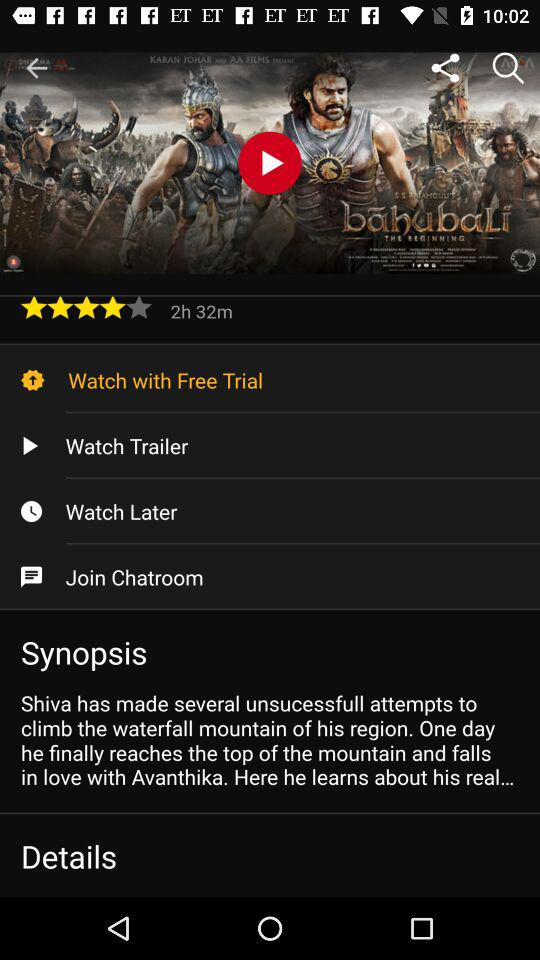What is the total duration of the movie? The total duration of the movie is 2 hours 32 minutes. 